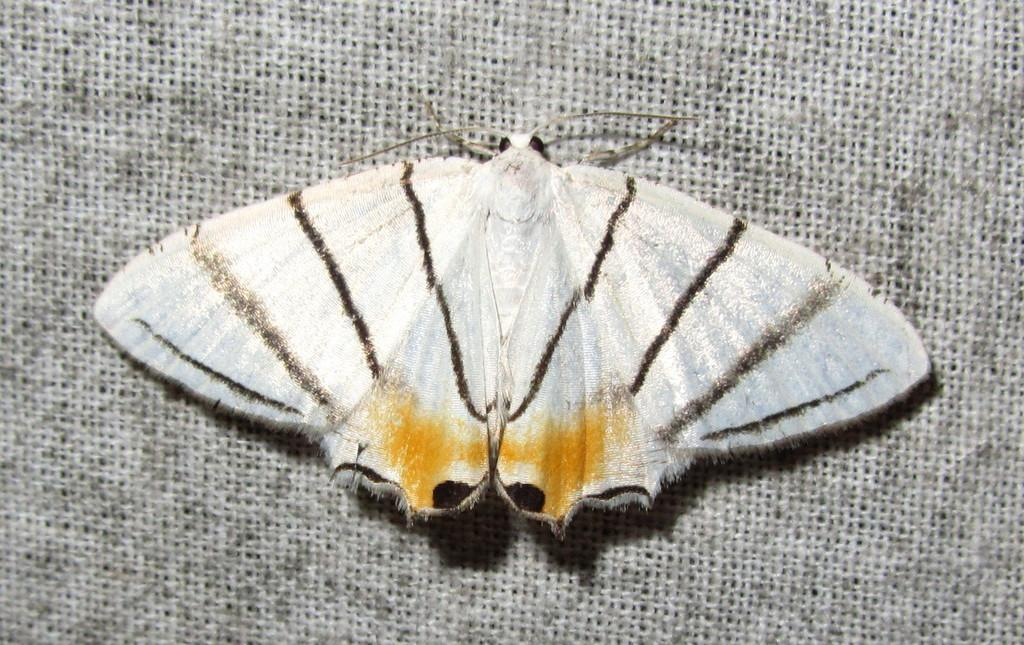What type of creature is present in the image? There is an insect in the image. Where is the insect located in the image? The insect is on a surface. What type of plantation is visible in the image? There is no plantation present in the image; it only features an insect on a surface. How many babies are visible in the image? There are no babies present in the image. 